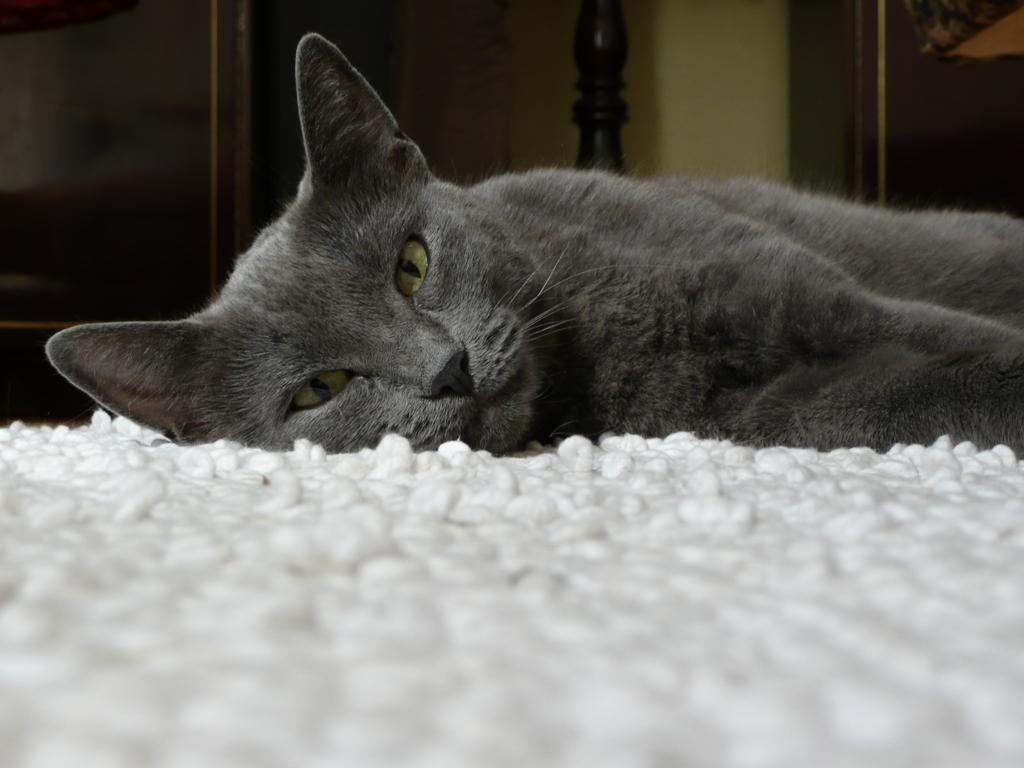What is placed on the floor in the image? There is a floor mat in the image. What type of animal can be seen in the image? There is a cat in the image. What is visible in the background of the image? There is a wall and objects visible in the background of the image. What type of tooth can be seen in the image? There is no tooth present in the image. How does the cat kick the ball in the image? There is no ball present in the image, and the cat is not shown performing any action like kicking. 